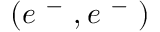<formula> <loc_0><loc_0><loc_500><loc_500>( e ^ { - } , e ^ { - } )</formula> 